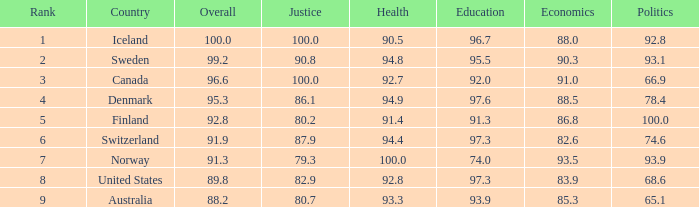What is the health index with equity at 8 93.3. 